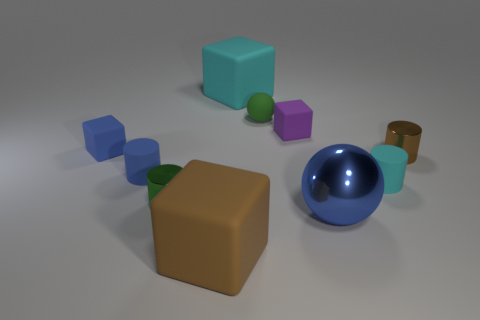Is there anything else of the same color as the large ball?
Keep it short and to the point. Yes. Are there any large brown blocks on the left side of the large cyan object?
Ensure brevity in your answer.  Yes. What is the size of the blue thing that is right of the big object that is behind the large blue ball?
Give a very brief answer. Large. Are there the same number of large rubber things in front of the cyan rubber cylinder and large blocks that are right of the small brown cylinder?
Ensure brevity in your answer.  No. There is a cyan matte thing in front of the small brown cylinder; is there a brown rubber object behind it?
Ensure brevity in your answer.  No. There is a tiny metallic thing on the left side of the tiny shiny object to the right of the big cyan object; how many brown metal cylinders are right of it?
Give a very brief answer. 1. Are there fewer brown cubes than brown shiny cubes?
Make the answer very short. No. There is a small green thing that is right of the large brown matte thing; is its shape the same as the cyan object on the right side of the purple object?
Give a very brief answer. No. What is the color of the tiny sphere?
Provide a succinct answer. Green. How many rubber things are brown objects or tiny green things?
Provide a succinct answer. 2. 